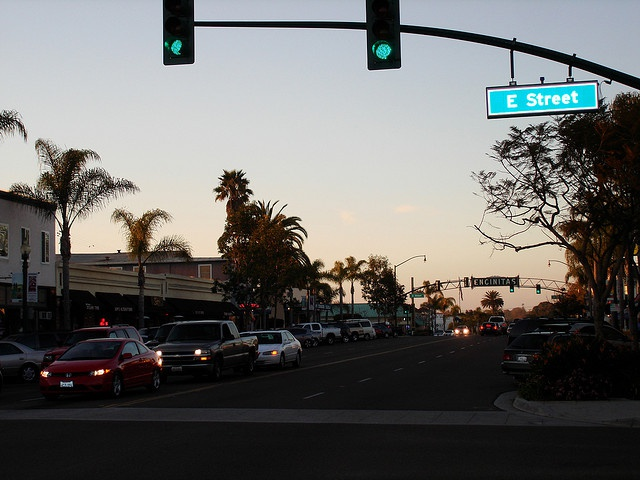Describe the objects in this image and their specific colors. I can see car in lightgray, black, maroon, gray, and purple tones, truck in lightgray, black, gray, maroon, and purple tones, car in lightgray, black, gray, and maroon tones, traffic light in lightgray, black, cyan, and turquoise tones, and traffic light in lightgray, black, turquoise, and green tones in this image. 